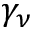Convert formula to latex. <formula><loc_0><loc_0><loc_500><loc_500>\gamma _ { \nu }</formula> 